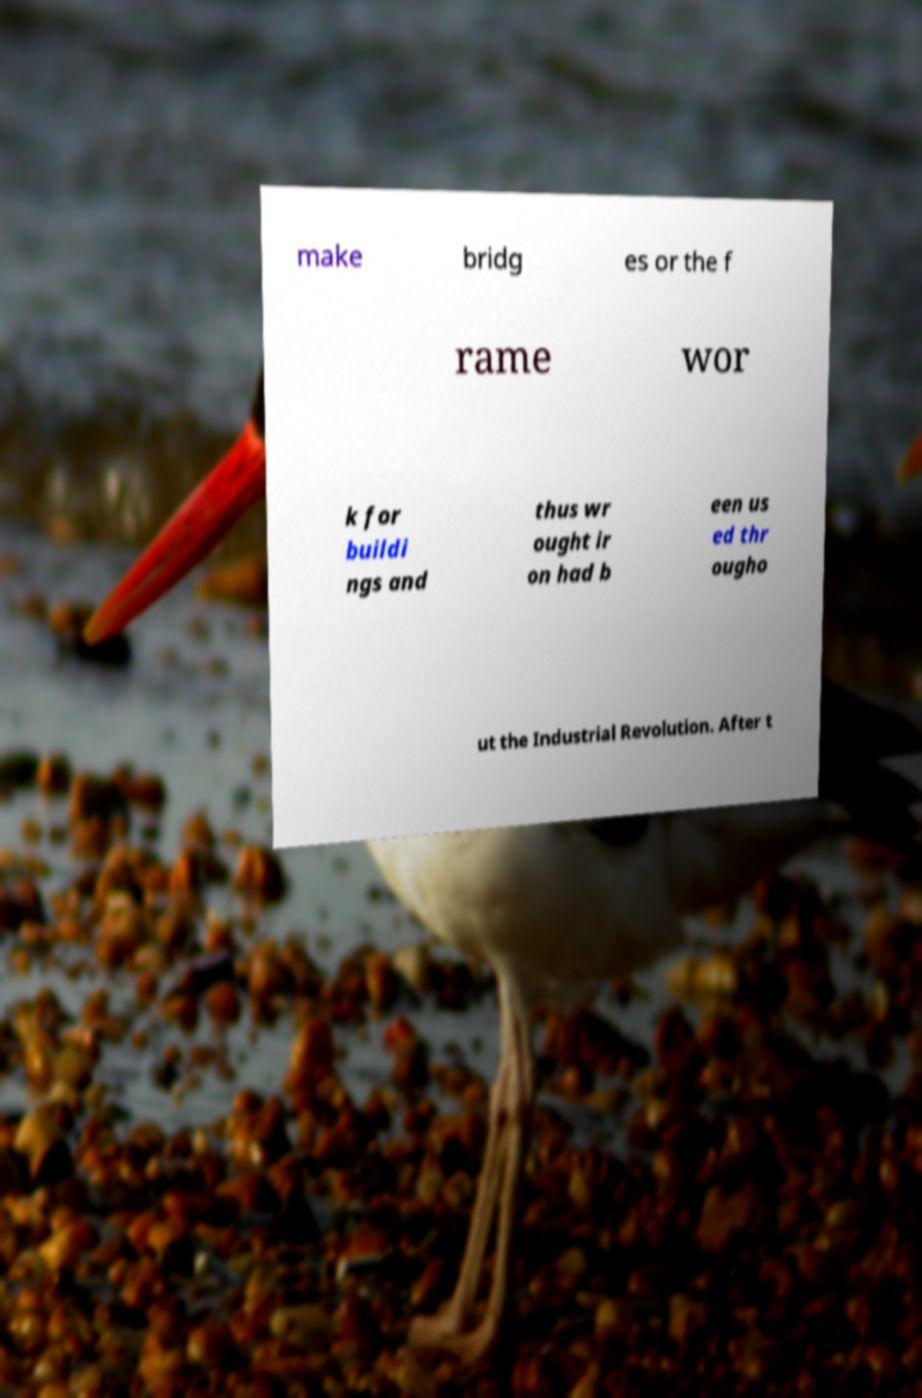Could you assist in decoding the text presented in this image and type it out clearly? make bridg es or the f rame wor k for buildi ngs and thus wr ought ir on had b een us ed thr ougho ut the Industrial Revolution. After t 